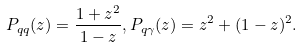<formula> <loc_0><loc_0><loc_500><loc_500>P _ { q q } ( z ) = \frac { 1 + z ^ { 2 } } { 1 - z } , P _ { q \gamma } ( z ) = z ^ { 2 } + ( 1 - z ) ^ { 2 } .</formula> 